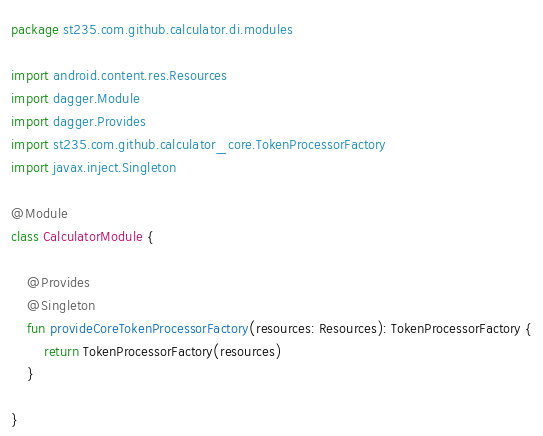<code> <loc_0><loc_0><loc_500><loc_500><_Kotlin_>package st235.com.github.calculator.di.modules

import android.content.res.Resources
import dagger.Module
import dagger.Provides
import st235.com.github.calculator_core.TokenProcessorFactory
import javax.inject.Singleton

@Module
class CalculatorModule {

    @Provides
    @Singleton
    fun provideCoreTokenProcessorFactory(resources: Resources): TokenProcessorFactory {
        return TokenProcessorFactory(resources)
    }

}
</code> 